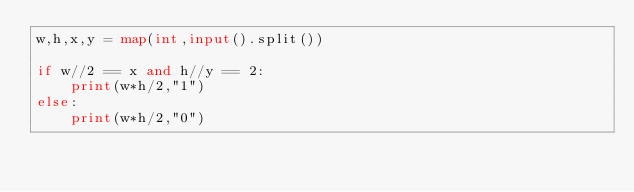Convert code to text. <code><loc_0><loc_0><loc_500><loc_500><_Python_>w,h,x,y = map(int,input().split())

if w//2 == x and h//y == 2:
    print(w*h/2,"1")
else:
    print(w*h/2,"0")

</code> 